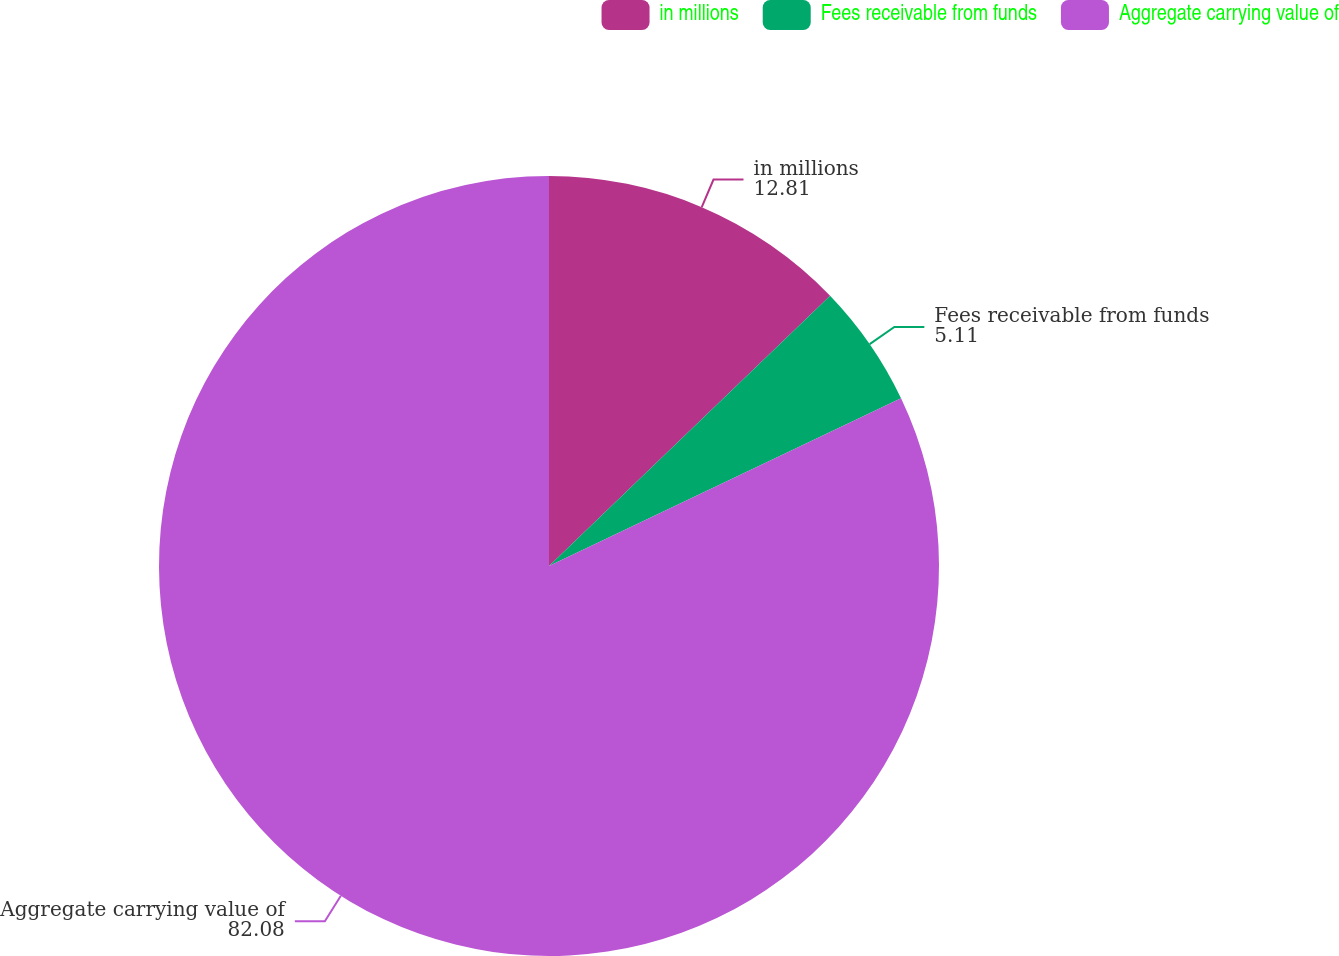<chart> <loc_0><loc_0><loc_500><loc_500><pie_chart><fcel>in millions<fcel>Fees receivable from funds<fcel>Aggregate carrying value of<nl><fcel>12.81%<fcel>5.11%<fcel>82.08%<nl></chart> 